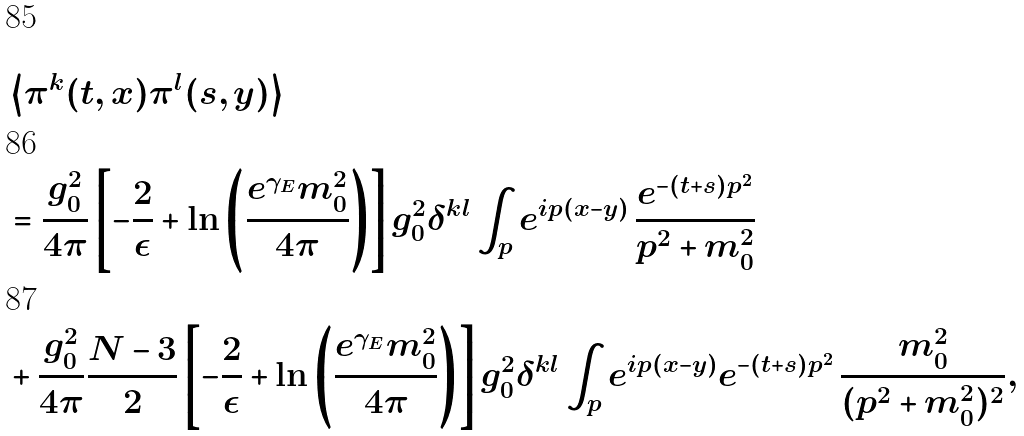Convert formula to latex. <formula><loc_0><loc_0><loc_500><loc_500>& \left \langle \pi ^ { k } ( t , x ) \pi ^ { l } ( s , y ) \right \rangle \\ & = \frac { g _ { 0 } ^ { 2 } } { 4 \pi } \left [ - \frac { 2 } { \epsilon } + \ln \left ( \frac { e ^ { \gamma _ { E } } m _ { 0 } ^ { 2 } } { 4 \pi } \right ) \right ] g _ { 0 } ^ { 2 } \delta ^ { k l } \int _ { p } e ^ { i p ( x - y ) } \, \frac { e ^ { - ( t + s ) p ^ { 2 } } } { p ^ { 2 } + m _ { 0 } ^ { 2 } } \\ & + \frac { g _ { 0 } ^ { 2 } } { 4 \pi } \frac { N - 3 } { 2 } \left [ - \frac { 2 } { \epsilon } + \ln \left ( \frac { e ^ { \gamma _ { E } } m _ { 0 } ^ { 2 } } { 4 \pi } \right ) \right ] g _ { 0 } ^ { 2 } \delta ^ { k l } \int _ { p } e ^ { i p ( x - y ) } e ^ { - ( t + s ) p ^ { 2 } } \, \frac { m _ { 0 } ^ { 2 } } { ( p ^ { 2 } + m _ { 0 } ^ { 2 } ) ^ { 2 } } ,</formula> 